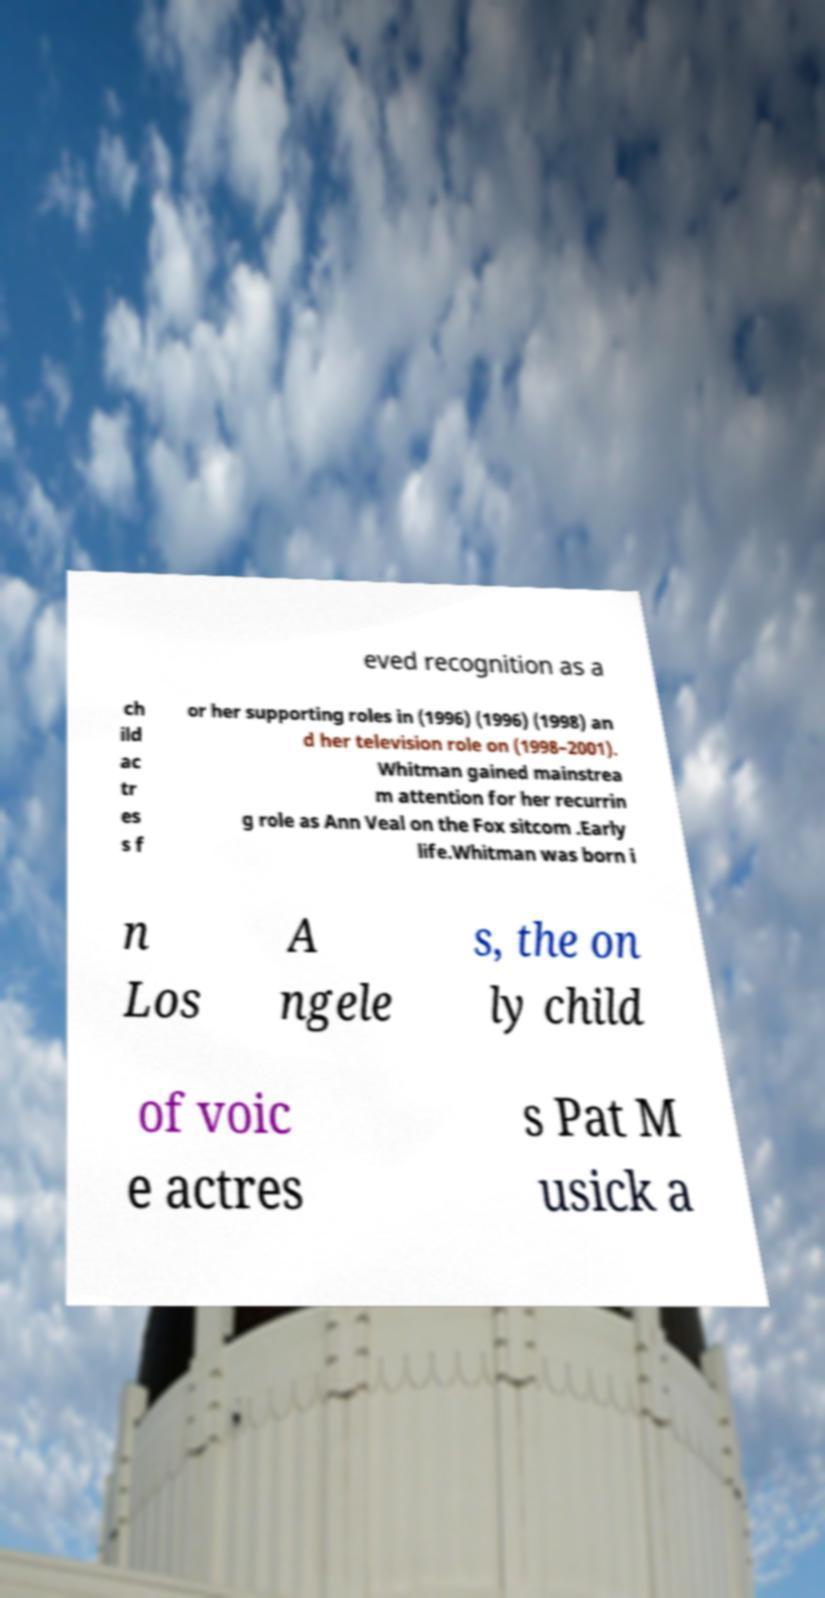Could you assist in decoding the text presented in this image and type it out clearly? eved recognition as a ch ild ac tr es s f or her supporting roles in (1996) (1996) (1998) an d her television role on (1998–2001). Whitman gained mainstrea m attention for her recurrin g role as Ann Veal on the Fox sitcom .Early life.Whitman was born i n Los A ngele s, the on ly child of voic e actres s Pat M usick a 